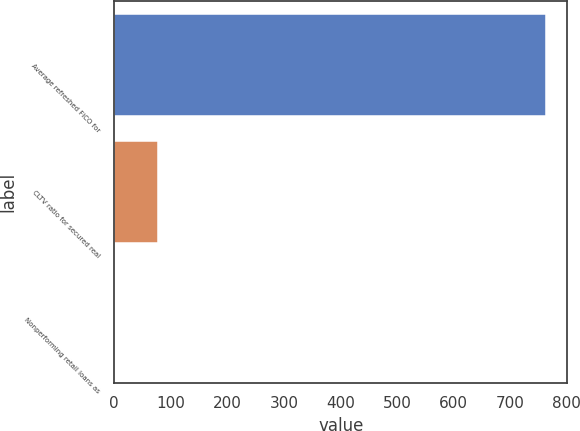Convert chart. <chart><loc_0><loc_0><loc_500><loc_500><bar_chart><fcel>Average refreshed FICO for<fcel>CLTV ratio for secured real<fcel>Nonperforming retail loans as<nl><fcel>763<fcel>77.2<fcel>1<nl></chart> 